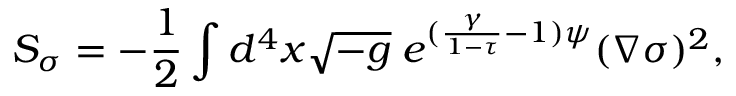<formula> <loc_0><loc_0><loc_500><loc_500>S _ { \sigma } = - \frac { 1 } { 2 } \int d ^ { 4 } x \sqrt { - g } \, e ^ { ( \frac { \gamma } { 1 - \tau } - 1 ) \psi } ( \nabla \sigma ) ^ { 2 } ,</formula> 